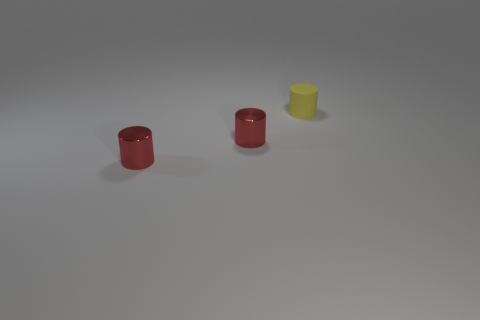Add 2 tiny things. How many objects exist? 5 Add 2 red metallic cylinders. How many red metallic cylinders are left? 4 Add 2 small red things. How many small red things exist? 4 Subtract 0 brown cylinders. How many objects are left? 3 Subtract all tiny things. Subtract all brown rubber cylinders. How many objects are left? 0 